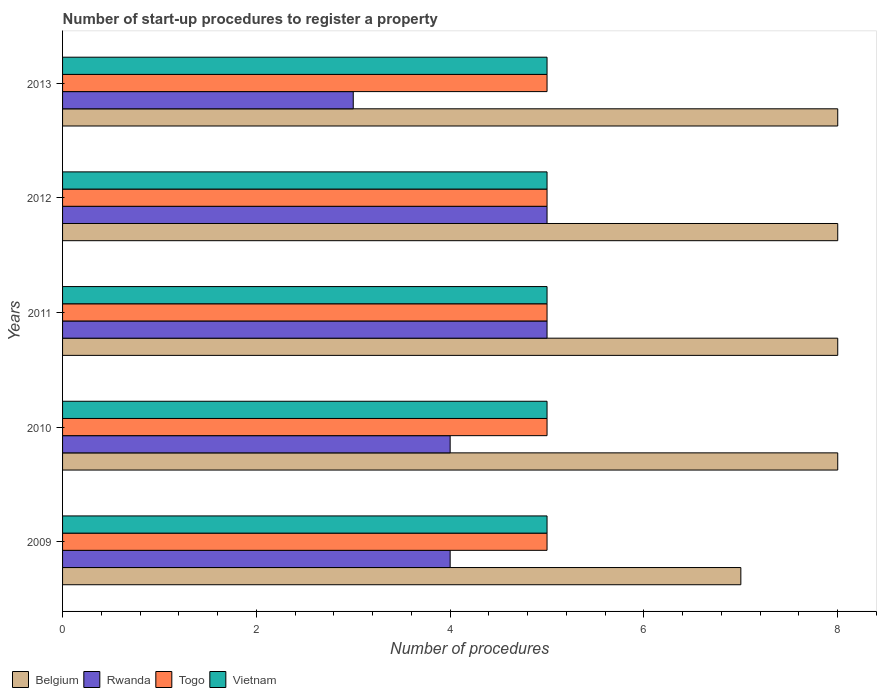How many different coloured bars are there?
Provide a short and direct response. 4. How many groups of bars are there?
Offer a terse response. 5. Are the number of bars on each tick of the Y-axis equal?
Provide a succinct answer. Yes. How many bars are there on the 2nd tick from the bottom?
Your answer should be very brief. 4. What is the label of the 3rd group of bars from the top?
Provide a succinct answer. 2011. In how many cases, is the number of bars for a given year not equal to the number of legend labels?
Offer a terse response. 0. What is the number of procedures required to register a property in Rwanda in 2013?
Make the answer very short. 3. Across all years, what is the maximum number of procedures required to register a property in Togo?
Your answer should be very brief. 5. Across all years, what is the minimum number of procedures required to register a property in Rwanda?
Ensure brevity in your answer.  3. In which year was the number of procedures required to register a property in Vietnam maximum?
Provide a succinct answer. 2009. In which year was the number of procedures required to register a property in Belgium minimum?
Give a very brief answer. 2009. What is the total number of procedures required to register a property in Belgium in the graph?
Provide a short and direct response. 39. What is the difference between the number of procedures required to register a property in Belgium in 2009 and that in 2013?
Your answer should be very brief. -1. What is the difference between the number of procedures required to register a property in Rwanda in 2010 and the number of procedures required to register a property in Vietnam in 2011?
Provide a succinct answer. -1. What is the average number of procedures required to register a property in Togo per year?
Ensure brevity in your answer.  5. In the year 2009, what is the difference between the number of procedures required to register a property in Vietnam and number of procedures required to register a property in Rwanda?
Ensure brevity in your answer.  1. In how many years, is the number of procedures required to register a property in Vietnam greater than 6 ?
Offer a terse response. 0. What is the ratio of the number of procedures required to register a property in Rwanda in 2010 to that in 2013?
Keep it short and to the point. 1.33. What is the difference between the highest and the lowest number of procedures required to register a property in Belgium?
Provide a succinct answer. 1. What does the 1st bar from the top in 2009 represents?
Your answer should be compact. Vietnam. What does the 3rd bar from the bottom in 2012 represents?
Ensure brevity in your answer.  Togo. How many bars are there?
Your answer should be very brief. 20. Are all the bars in the graph horizontal?
Provide a succinct answer. Yes. What is the difference between two consecutive major ticks on the X-axis?
Give a very brief answer. 2. Are the values on the major ticks of X-axis written in scientific E-notation?
Provide a succinct answer. No. Does the graph contain grids?
Offer a very short reply. No. How many legend labels are there?
Your answer should be compact. 4. What is the title of the graph?
Your response must be concise. Number of start-up procedures to register a property. What is the label or title of the X-axis?
Ensure brevity in your answer.  Number of procedures. What is the Number of procedures of Belgium in 2009?
Keep it short and to the point. 7. What is the Number of procedures of Rwanda in 2009?
Your answer should be compact. 4. What is the Number of procedures of Vietnam in 2009?
Your response must be concise. 5. What is the Number of procedures of Belgium in 2010?
Provide a succinct answer. 8. What is the Number of procedures in Rwanda in 2010?
Ensure brevity in your answer.  4. What is the Number of procedures of Belgium in 2011?
Offer a terse response. 8. What is the Number of procedures in Rwanda in 2011?
Ensure brevity in your answer.  5. What is the Number of procedures of Belgium in 2012?
Your response must be concise. 8. What is the Number of procedures of Rwanda in 2012?
Your answer should be very brief. 5. What is the Number of procedures of Rwanda in 2013?
Make the answer very short. 3. What is the Number of procedures in Togo in 2013?
Ensure brevity in your answer.  5. Across all years, what is the maximum Number of procedures of Belgium?
Give a very brief answer. 8. Across all years, what is the maximum Number of procedures in Rwanda?
Give a very brief answer. 5. Across all years, what is the minimum Number of procedures in Rwanda?
Offer a very short reply. 3. Across all years, what is the minimum Number of procedures in Vietnam?
Provide a short and direct response. 5. What is the total Number of procedures in Rwanda in the graph?
Make the answer very short. 21. What is the difference between the Number of procedures of Belgium in 2009 and that in 2010?
Give a very brief answer. -1. What is the difference between the Number of procedures in Rwanda in 2009 and that in 2010?
Your response must be concise. 0. What is the difference between the Number of procedures in Togo in 2009 and that in 2010?
Keep it short and to the point. 0. What is the difference between the Number of procedures of Belgium in 2009 and that in 2011?
Your answer should be very brief. -1. What is the difference between the Number of procedures of Rwanda in 2009 and that in 2011?
Offer a very short reply. -1. What is the difference between the Number of procedures of Rwanda in 2009 and that in 2012?
Keep it short and to the point. -1. What is the difference between the Number of procedures in Togo in 2009 and that in 2013?
Ensure brevity in your answer.  0. What is the difference between the Number of procedures in Belgium in 2010 and that in 2011?
Your response must be concise. 0. What is the difference between the Number of procedures in Rwanda in 2010 and that in 2011?
Your answer should be very brief. -1. What is the difference between the Number of procedures in Togo in 2010 and that in 2011?
Keep it short and to the point. 0. What is the difference between the Number of procedures of Vietnam in 2010 and that in 2011?
Offer a terse response. 0. What is the difference between the Number of procedures in Belgium in 2010 and that in 2012?
Your response must be concise. 0. What is the difference between the Number of procedures of Rwanda in 2010 and that in 2012?
Provide a succinct answer. -1. What is the difference between the Number of procedures of Togo in 2010 and that in 2012?
Provide a succinct answer. 0. What is the difference between the Number of procedures of Vietnam in 2010 and that in 2012?
Your response must be concise. 0. What is the difference between the Number of procedures of Togo in 2010 and that in 2013?
Provide a short and direct response. 0. What is the difference between the Number of procedures of Rwanda in 2011 and that in 2012?
Offer a terse response. 0. What is the difference between the Number of procedures in Rwanda in 2011 and that in 2013?
Offer a very short reply. 2. What is the difference between the Number of procedures in Vietnam in 2011 and that in 2013?
Keep it short and to the point. 0. What is the difference between the Number of procedures of Belgium in 2012 and that in 2013?
Provide a short and direct response. 0. What is the difference between the Number of procedures of Rwanda in 2012 and that in 2013?
Your response must be concise. 2. What is the difference between the Number of procedures of Vietnam in 2012 and that in 2013?
Give a very brief answer. 0. What is the difference between the Number of procedures of Belgium in 2009 and the Number of procedures of Rwanda in 2010?
Your answer should be compact. 3. What is the difference between the Number of procedures of Belgium in 2009 and the Number of procedures of Vietnam in 2010?
Your response must be concise. 2. What is the difference between the Number of procedures in Rwanda in 2009 and the Number of procedures in Togo in 2010?
Offer a terse response. -1. What is the difference between the Number of procedures of Belgium in 2009 and the Number of procedures of Rwanda in 2011?
Ensure brevity in your answer.  2. What is the difference between the Number of procedures in Rwanda in 2009 and the Number of procedures in Togo in 2011?
Make the answer very short. -1. What is the difference between the Number of procedures in Rwanda in 2009 and the Number of procedures in Vietnam in 2011?
Provide a short and direct response. -1. What is the difference between the Number of procedures in Rwanda in 2009 and the Number of procedures in Vietnam in 2012?
Make the answer very short. -1. What is the difference between the Number of procedures in Belgium in 2009 and the Number of procedures in Rwanda in 2013?
Offer a very short reply. 4. What is the difference between the Number of procedures of Rwanda in 2009 and the Number of procedures of Togo in 2013?
Give a very brief answer. -1. What is the difference between the Number of procedures of Rwanda in 2009 and the Number of procedures of Vietnam in 2013?
Make the answer very short. -1. What is the difference between the Number of procedures in Togo in 2009 and the Number of procedures in Vietnam in 2013?
Offer a terse response. 0. What is the difference between the Number of procedures in Belgium in 2010 and the Number of procedures in Rwanda in 2011?
Ensure brevity in your answer.  3. What is the difference between the Number of procedures of Rwanda in 2010 and the Number of procedures of Togo in 2011?
Offer a very short reply. -1. What is the difference between the Number of procedures of Rwanda in 2010 and the Number of procedures of Vietnam in 2011?
Keep it short and to the point. -1. What is the difference between the Number of procedures of Togo in 2010 and the Number of procedures of Vietnam in 2011?
Your response must be concise. 0. What is the difference between the Number of procedures in Rwanda in 2010 and the Number of procedures in Vietnam in 2012?
Offer a very short reply. -1. What is the difference between the Number of procedures of Togo in 2010 and the Number of procedures of Vietnam in 2012?
Offer a terse response. 0. What is the difference between the Number of procedures of Belgium in 2010 and the Number of procedures of Togo in 2013?
Your answer should be very brief. 3. What is the difference between the Number of procedures in Belgium in 2010 and the Number of procedures in Vietnam in 2013?
Give a very brief answer. 3. What is the difference between the Number of procedures in Rwanda in 2010 and the Number of procedures in Togo in 2013?
Provide a succinct answer. -1. What is the difference between the Number of procedures in Belgium in 2011 and the Number of procedures in Rwanda in 2012?
Ensure brevity in your answer.  3. What is the difference between the Number of procedures of Belgium in 2011 and the Number of procedures of Vietnam in 2012?
Offer a very short reply. 3. What is the difference between the Number of procedures of Rwanda in 2011 and the Number of procedures of Togo in 2012?
Provide a succinct answer. 0. What is the difference between the Number of procedures of Togo in 2011 and the Number of procedures of Vietnam in 2012?
Your answer should be compact. 0. What is the difference between the Number of procedures in Belgium in 2011 and the Number of procedures in Togo in 2013?
Make the answer very short. 3. What is the difference between the Number of procedures of Rwanda in 2011 and the Number of procedures of Vietnam in 2013?
Make the answer very short. 0. What is the difference between the Number of procedures in Belgium in 2012 and the Number of procedures in Rwanda in 2013?
Provide a succinct answer. 5. What is the difference between the Number of procedures in Belgium in 2012 and the Number of procedures in Togo in 2013?
Your answer should be compact. 3. What is the difference between the Number of procedures in Rwanda in 2012 and the Number of procedures in Vietnam in 2013?
Make the answer very short. 0. What is the average Number of procedures in Belgium per year?
Provide a succinct answer. 7.8. What is the average Number of procedures of Rwanda per year?
Offer a very short reply. 4.2. In the year 2009, what is the difference between the Number of procedures of Belgium and Number of procedures of Rwanda?
Keep it short and to the point. 3. In the year 2009, what is the difference between the Number of procedures of Rwanda and Number of procedures of Togo?
Ensure brevity in your answer.  -1. In the year 2009, what is the difference between the Number of procedures of Rwanda and Number of procedures of Vietnam?
Offer a terse response. -1. In the year 2009, what is the difference between the Number of procedures in Togo and Number of procedures in Vietnam?
Your response must be concise. 0. In the year 2010, what is the difference between the Number of procedures of Belgium and Number of procedures of Togo?
Offer a terse response. 3. In the year 2010, what is the difference between the Number of procedures in Belgium and Number of procedures in Vietnam?
Offer a terse response. 3. In the year 2010, what is the difference between the Number of procedures of Rwanda and Number of procedures of Togo?
Keep it short and to the point. -1. In the year 2010, what is the difference between the Number of procedures in Rwanda and Number of procedures in Vietnam?
Offer a very short reply. -1. In the year 2011, what is the difference between the Number of procedures in Belgium and Number of procedures in Togo?
Ensure brevity in your answer.  3. In the year 2011, what is the difference between the Number of procedures of Rwanda and Number of procedures of Togo?
Ensure brevity in your answer.  0. In the year 2012, what is the difference between the Number of procedures in Rwanda and Number of procedures in Togo?
Provide a succinct answer. 0. In the year 2012, what is the difference between the Number of procedures of Togo and Number of procedures of Vietnam?
Offer a very short reply. 0. In the year 2013, what is the difference between the Number of procedures in Belgium and Number of procedures in Rwanda?
Provide a short and direct response. 5. In the year 2013, what is the difference between the Number of procedures of Rwanda and Number of procedures of Vietnam?
Your response must be concise. -2. What is the ratio of the Number of procedures of Rwanda in 2009 to that in 2010?
Provide a succinct answer. 1. What is the ratio of the Number of procedures in Togo in 2009 to that in 2010?
Your answer should be compact. 1. What is the ratio of the Number of procedures of Rwanda in 2009 to that in 2011?
Provide a succinct answer. 0.8. What is the ratio of the Number of procedures of Vietnam in 2009 to that in 2011?
Keep it short and to the point. 1. What is the ratio of the Number of procedures of Belgium in 2009 to that in 2012?
Ensure brevity in your answer.  0.88. What is the ratio of the Number of procedures in Rwanda in 2009 to that in 2012?
Make the answer very short. 0.8. What is the ratio of the Number of procedures in Togo in 2009 to that in 2012?
Your answer should be compact. 1. What is the ratio of the Number of procedures in Vietnam in 2009 to that in 2012?
Offer a terse response. 1. What is the ratio of the Number of procedures in Rwanda in 2009 to that in 2013?
Your answer should be very brief. 1.33. What is the ratio of the Number of procedures in Togo in 2009 to that in 2013?
Your answer should be very brief. 1. What is the ratio of the Number of procedures of Belgium in 2010 to that in 2011?
Provide a succinct answer. 1. What is the ratio of the Number of procedures in Rwanda in 2010 to that in 2011?
Make the answer very short. 0.8. What is the ratio of the Number of procedures in Belgium in 2010 to that in 2012?
Make the answer very short. 1. What is the ratio of the Number of procedures in Rwanda in 2010 to that in 2012?
Keep it short and to the point. 0.8. What is the ratio of the Number of procedures in Vietnam in 2010 to that in 2012?
Offer a very short reply. 1. What is the ratio of the Number of procedures in Togo in 2010 to that in 2013?
Provide a succinct answer. 1. What is the ratio of the Number of procedures in Vietnam in 2010 to that in 2013?
Your response must be concise. 1. What is the ratio of the Number of procedures in Belgium in 2011 to that in 2012?
Your response must be concise. 1. What is the ratio of the Number of procedures in Rwanda in 2011 to that in 2012?
Your answer should be very brief. 1. What is the ratio of the Number of procedures in Vietnam in 2011 to that in 2012?
Your answer should be compact. 1. What is the ratio of the Number of procedures in Togo in 2011 to that in 2013?
Your answer should be compact. 1. What is the difference between the highest and the second highest Number of procedures of Vietnam?
Provide a short and direct response. 0. What is the difference between the highest and the lowest Number of procedures of Belgium?
Provide a succinct answer. 1. What is the difference between the highest and the lowest Number of procedures of Togo?
Provide a short and direct response. 0. What is the difference between the highest and the lowest Number of procedures of Vietnam?
Make the answer very short. 0. 